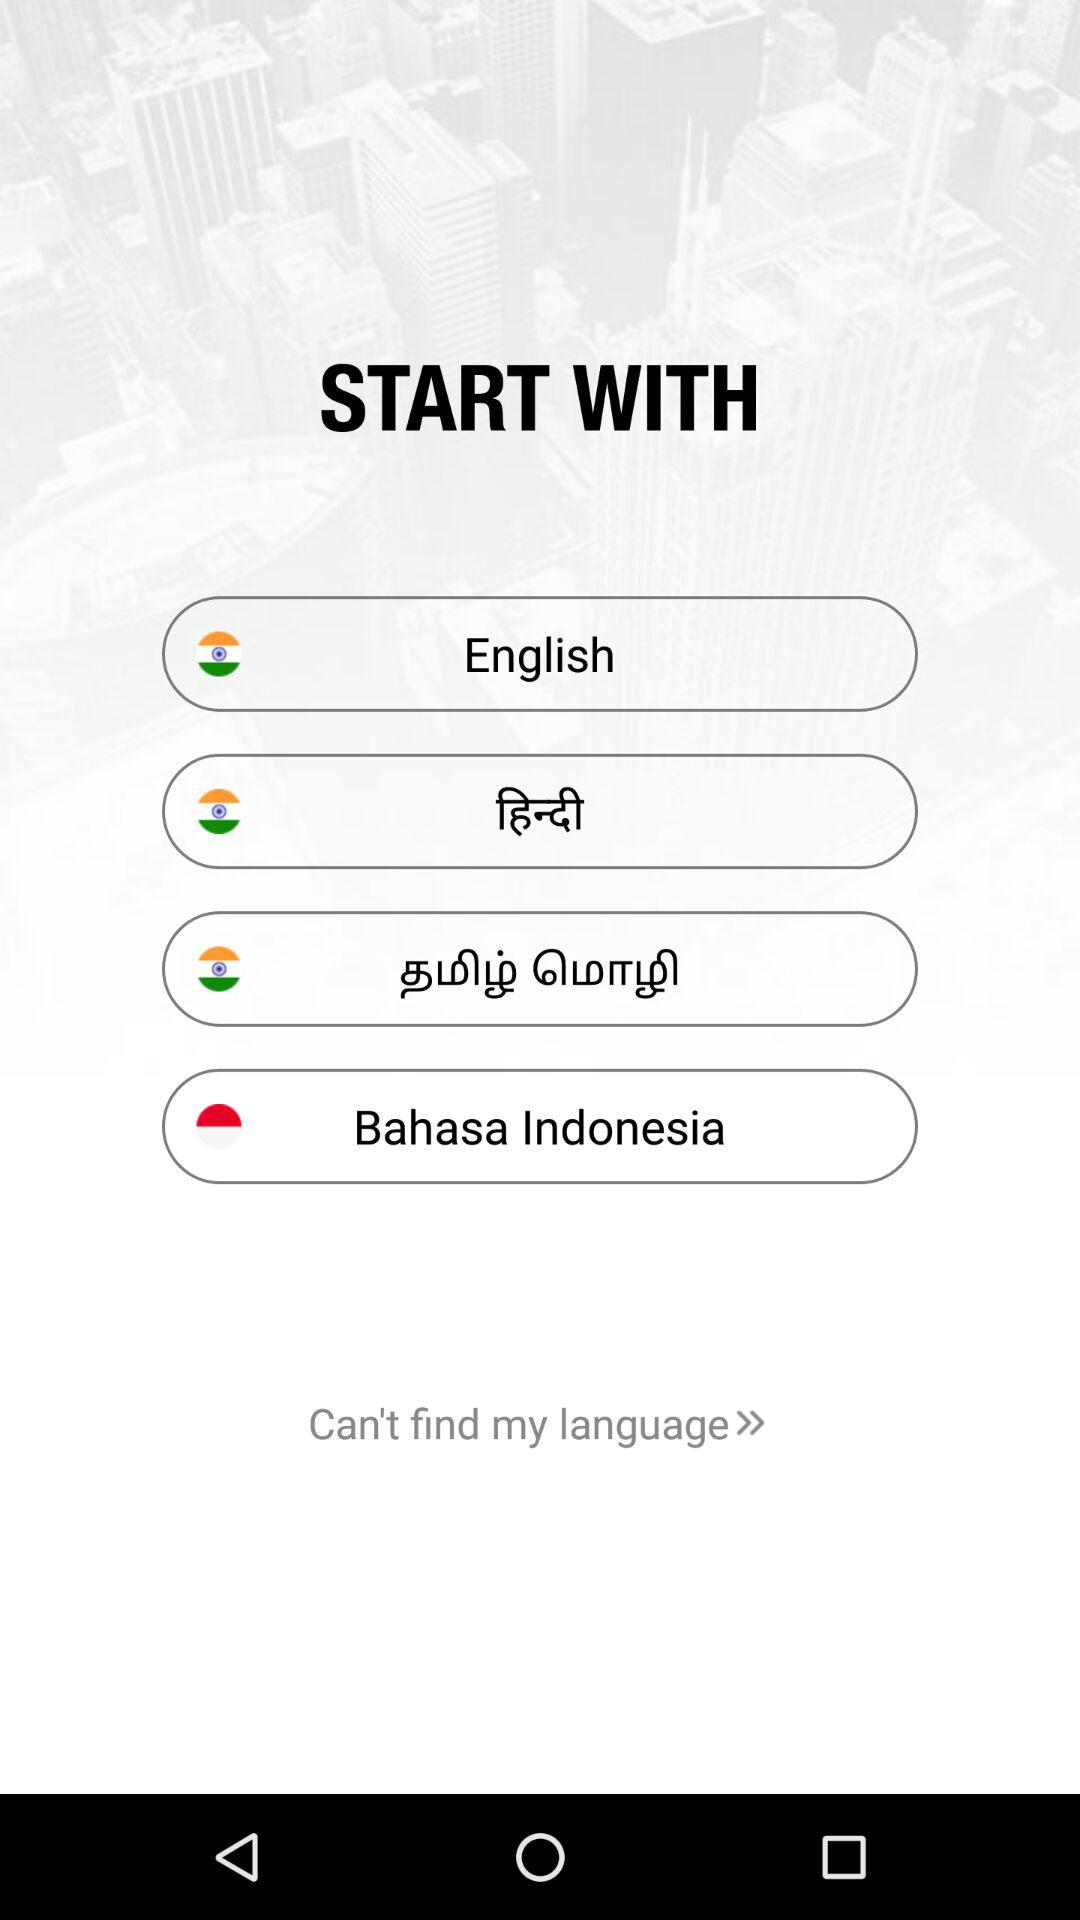How many languages are available to choose from?
Answer the question using a single word or phrase. 4 